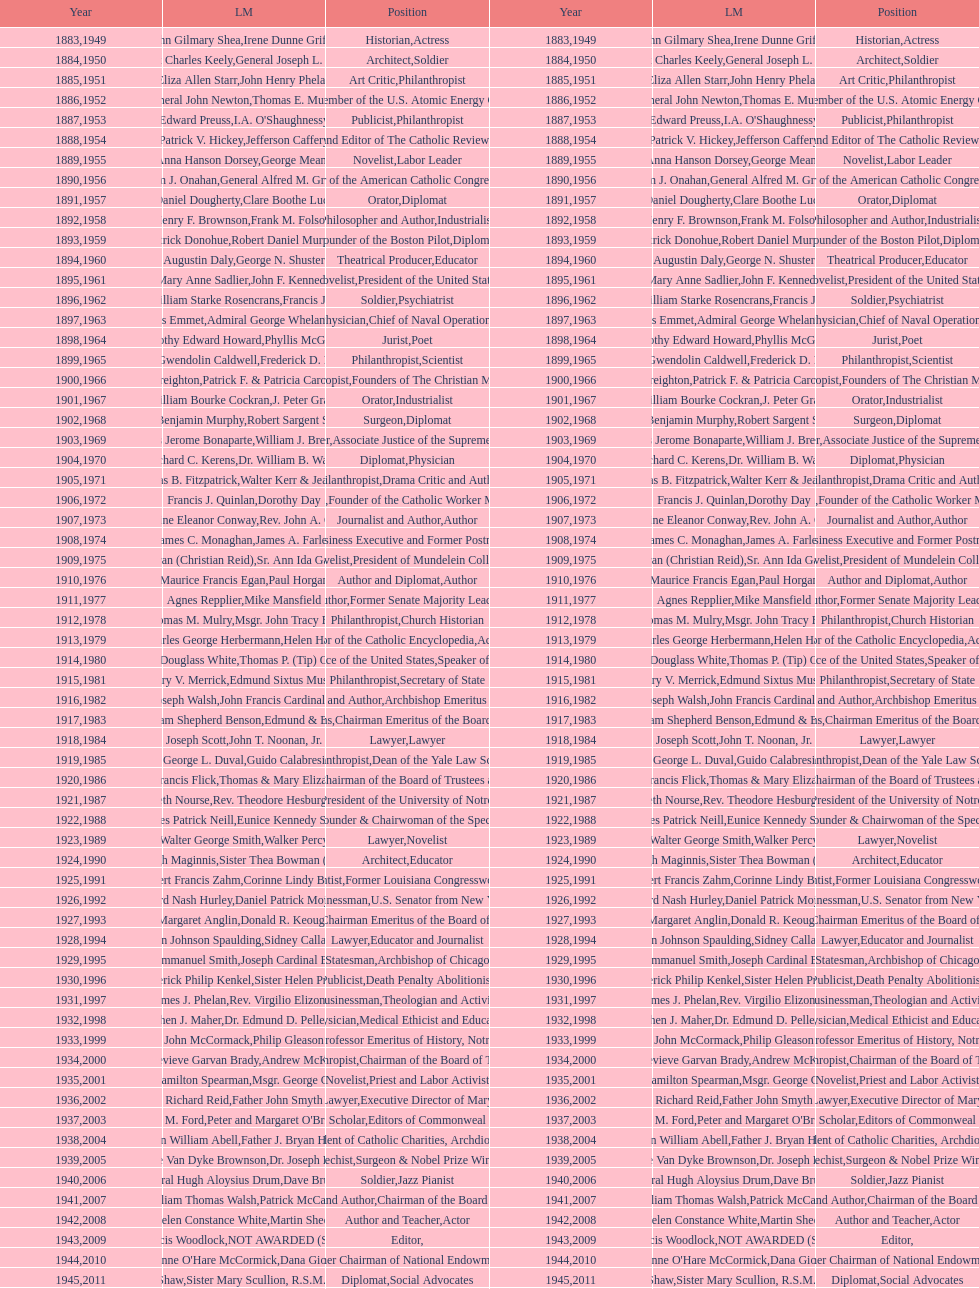Who was the previous winner before john henry phelan in 1951? General Joseph L. Collins. 